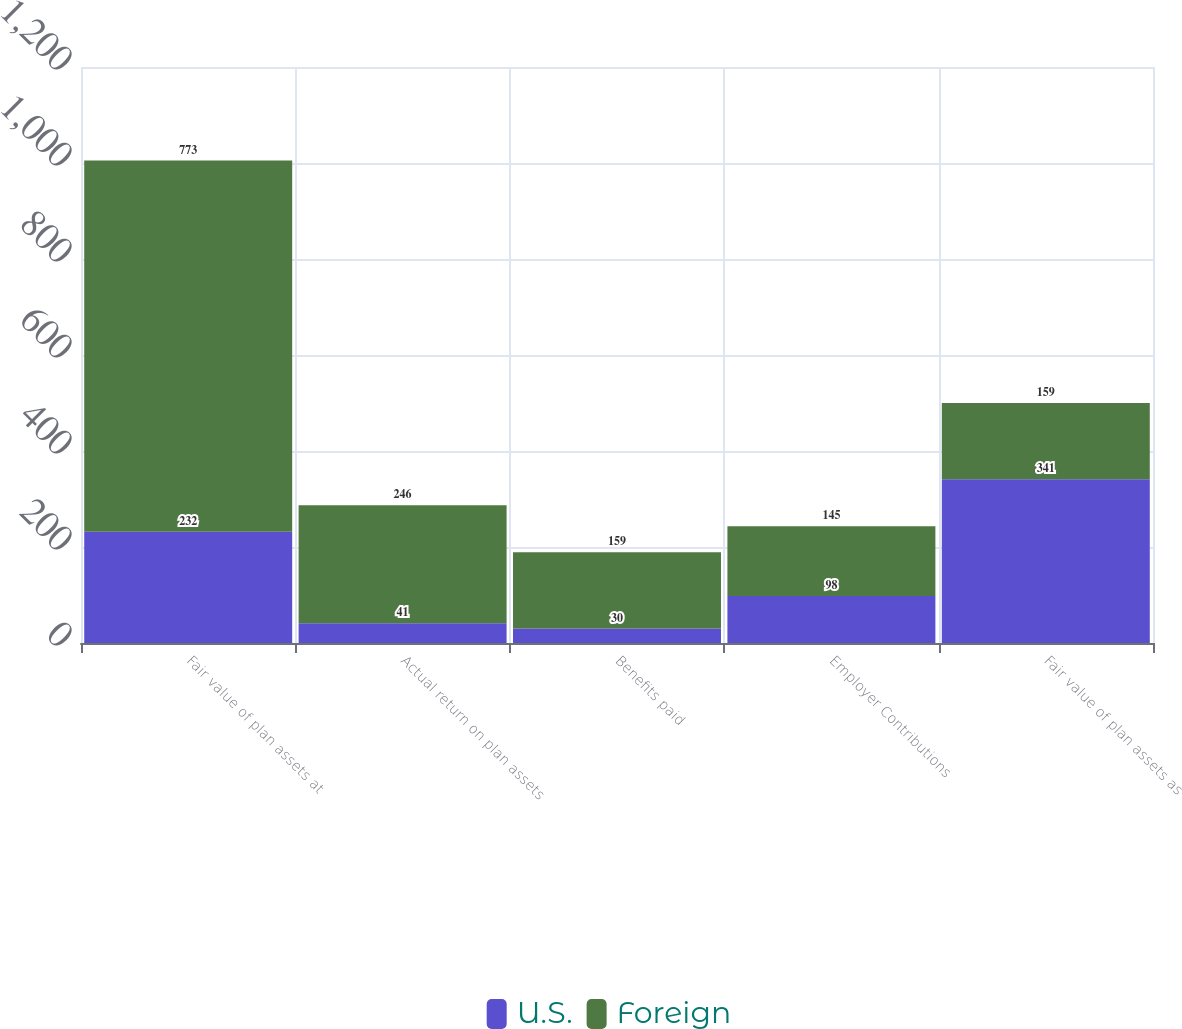Convert chart. <chart><loc_0><loc_0><loc_500><loc_500><stacked_bar_chart><ecel><fcel>Fair value of plan assets at<fcel>Actual return on plan assets<fcel>Benefits paid<fcel>Employer Contributions<fcel>Fair value of plan assets as<nl><fcel>U.S.<fcel>232<fcel>41<fcel>30<fcel>98<fcel>341<nl><fcel>Foreign<fcel>773<fcel>246<fcel>159<fcel>145<fcel>159<nl></chart> 